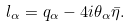<formula> <loc_0><loc_0><loc_500><loc_500>l _ { \alpha } = q _ { \alpha } - 4 i \theta _ { \alpha } \bar { \eta } .</formula> 